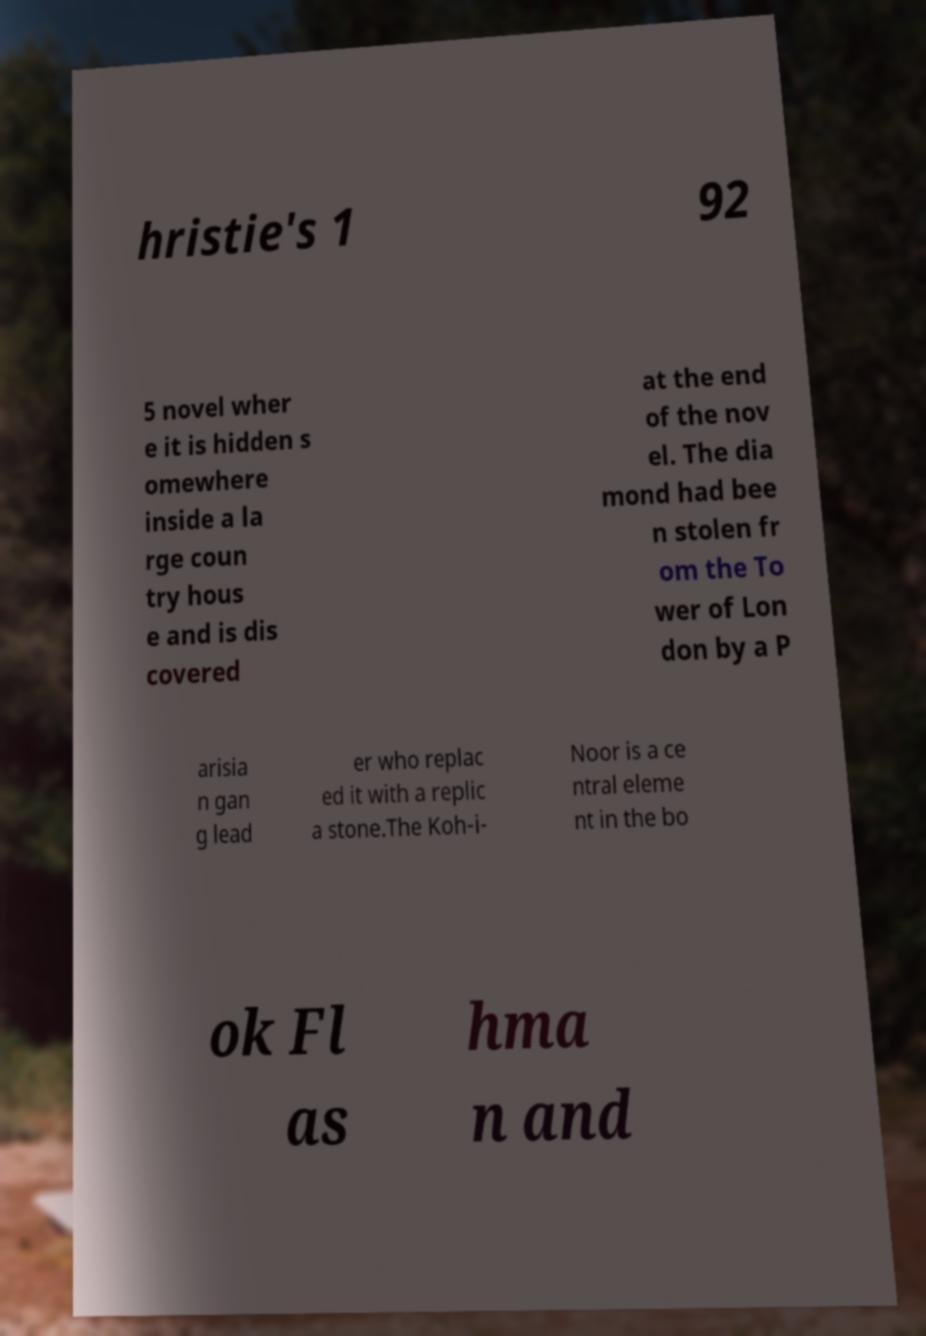Could you extract and type out the text from this image? hristie's 1 92 5 novel wher e it is hidden s omewhere inside a la rge coun try hous e and is dis covered at the end of the nov el. The dia mond had bee n stolen fr om the To wer of Lon don by a P arisia n gan g lead er who replac ed it with a replic a stone.The Koh-i- Noor is a ce ntral eleme nt in the bo ok Fl as hma n and 